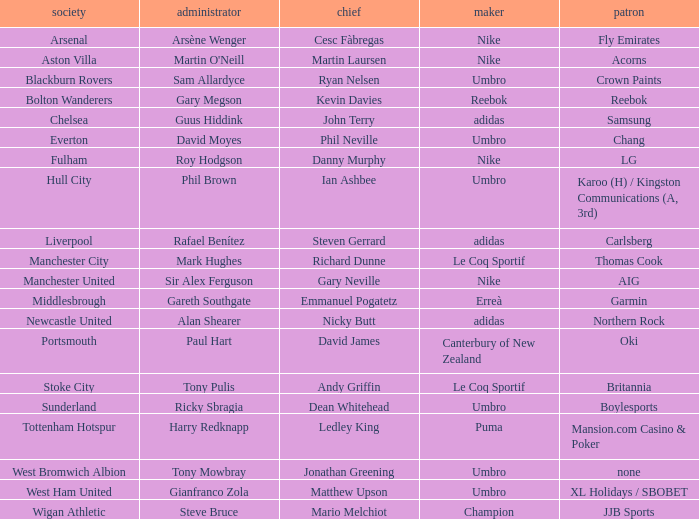In which club is Ledley King a captain? Tottenham Hotspur. Could you parse the entire table? {'header': ['society', 'administrator', 'chief', 'maker', 'patron'], 'rows': [['Arsenal', 'Arsène Wenger', 'Cesc Fàbregas', 'Nike', 'Fly Emirates'], ['Aston Villa', "Martin O'Neill", 'Martin Laursen', 'Nike', 'Acorns'], ['Blackburn Rovers', 'Sam Allardyce', 'Ryan Nelsen', 'Umbro', 'Crown Paints'], ['Bolton Wanderers', 'Gary Megson', 'Kevin Davies', 'Reebok', 'Reebok'], ['Chelsea', 'Guus Hiddink', 'John Terry', 'adidas', 'Samsung'], ['Everton', 'David Moyes', 'Phil Neville', 'Umbro', 'Chang'], ['Fulham', 'Roy Hodgson', 'Danny Murphy', 'Nike', 'LG'], ['Hull City', 'Phil Brown', 'Ian Ashbee', 'Umbro', 'Karoo (H) / Kingston Communications (A, 3rd)'], ['Liverpool', 'Rafael Benítez', 'Steven Gerrard', 'adidas', 'Carlsberg'], ['Manchester City', 'Mark Hughes', 'Richard Dunne', 'Le Coq Sportif', 'Thomas Cook'], ['Manchester United', 'Sir Alex Ferguson', 'Gary Neville', 'Nike', 'AIG'], ['Middlesbrough', 'Gareth Southgate', 'Emmanuel Pogatetz', 'Erreà', 'Garmin'], ['Newcastle United', 'Alan Shearer', 'Nicky Butt', 'adidas', 'Northern Rock'], ['Portsmouth', 'Paul Hart', 'David James', 'Canterbury of New Zealand', 'Oki'], ['Stoke City', 'Tony Pulis', 'Andy Griffin', 'Le Coq Sportif', 'Britannia'], ['Sunderland', 'Ricky Sbragia', 'Dean Whitehead', 'Umbro', 'Boylesports'], ['Tottenham Hotspur', 'Harry Redknapp', 'Ledley King', 'Puma', 'Mansion.com Casino & Poker'], ['West Bromwich Albion', 'Tony Mowbray', 'Jonathan Greening', 'Umbro', 'none'], ['West Ham United', 'Gianfranco Zola', 'Matthew Upson', 'Umbro', 'XL Holidays / SBOBET'], ['Wigan Athletic', 'Steve Bruce', 'Mario Melchiot', 'Champion', 'JJB Sports']]} 